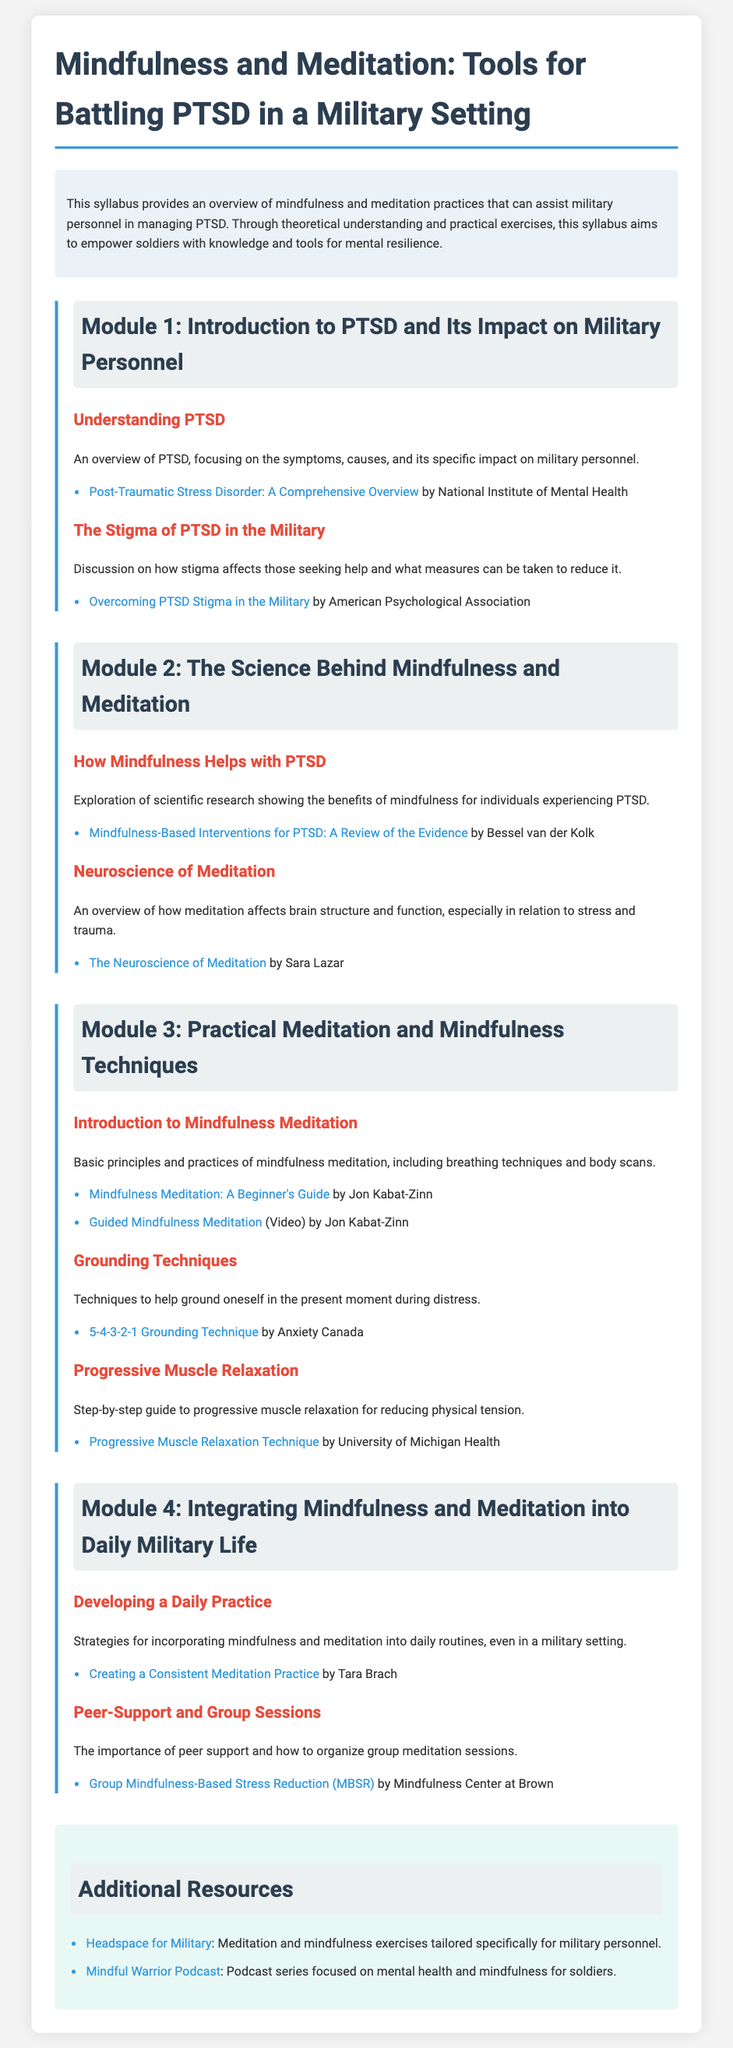what is the title of the syllabus? The title is stated at the top of the syllabus, which is "Mindfulness and Meditation: Tools for Battling PTSD in a Military Setting."
Answer: Mindfulness and Meditation: Tools for Battling PTSD in a Military Setting how many modules are in the syllabus? The syllabus contains four distinct modules focusing on different aspects of mindfulness, meditation, and PTSD.
Answer: Four who is the author of the resource on mindfulness-based interventions for PTSD? The author is mentioned in the reference section of Module 2, specifically concerning the review of evidence for mindfulness-based interventions.
Answer: Bessel van der Kolk what technique is introduced in Module 3 for grounding oneself? The specific technique introduced in Module 3 for grounding oneself in the present moment during distress is outlined in the title of the corresponding section.
Answer: 5-4-3-2-1 Grounding Technique what is the purpose of the "Additional Resources" section? This section provides supplementary links and materials related to mindfulness and meditation tailored for military personnel.
Answer: Supplementary links and materials what is the main theme of Module 1? This module centers around understanding PTSD, its symptoms, and the stigma associated with it within military contexts.
Answer: Understanding PTSD what practical technique is discussed for reducing physical tension? The syllabus outlines a specific technique in Module 3 targeted at reducing physical tension effectively.
Answer: Progressive Muscle Relaxation how does the syllabus suggest integrating mindfulness into military life? In Module 4, strategies are discussed for incorporating mindfulness and meditation practices into daily military routines.
Answer: Incorporating mindfulness and meditation practices 